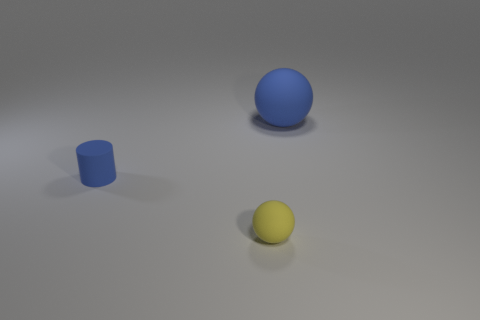Add 2 large green metallic objects. How many objects exist? 5 Subtract all spheres. How many objects are left? 1 Add 1 blue matte things. How many blue matte things are left? 3 Add 1 big blue matte balls. How many big blue matte balls exist? 2 Subtract 0 cyan cubes. How many objects are left? 3 Subtract all blue rubber balls. Subtract all small purple shiny cubes. How many objects are left? 2 